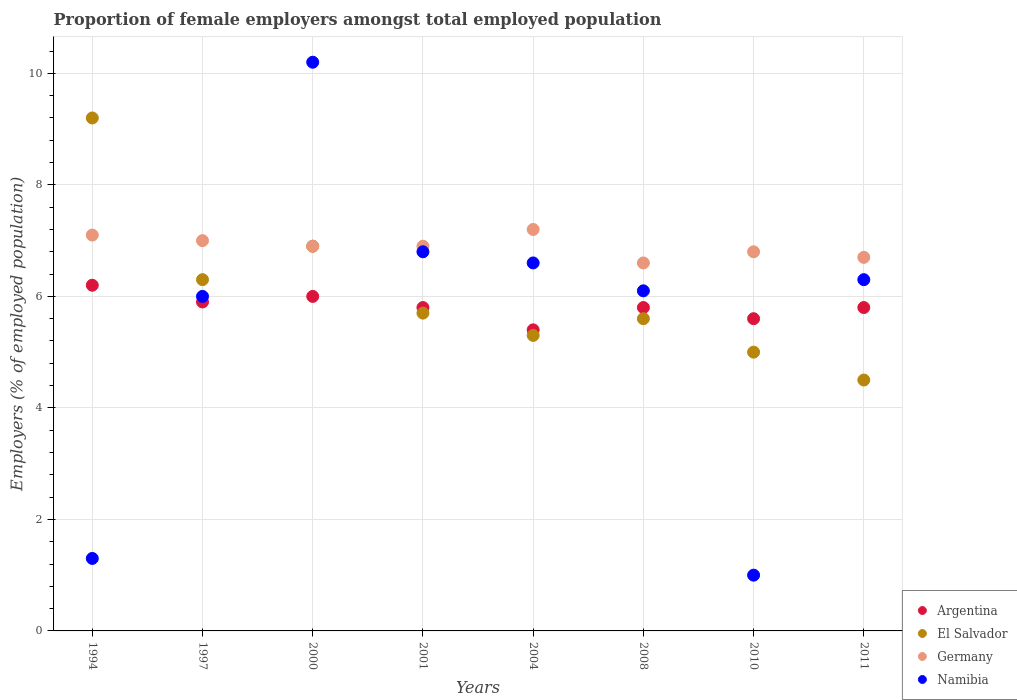How many different coloured dotlines are there?
Your response must be concise. 4. What is the proportion of female employers in Argentina in 1997?
Your response must be concise. 5.9. Across all years, what is the maximum proportion of female employers in El Salvador?
Ensure brevity in your answer.  9.2. Across all years, what is the minimum proportion of female employers in El Salvador?
Your answer should be very brief. 4.5. What is the total proportion of female employers in Argentina in the graph?
Make the answer very short. 46.5. What is the difference between the proportion of female employers in El Salvador in 2004 and that in 2008?
Provide a short and direct response. -0.3. What is the difference between the proportion of female employers in Argentina in 2011 and the proportion of female employers in El Salvador in 2010?
Keep it short and to the point. 0.8. What is the average proportion of female employers in Namibia per year?
Make the answer very short. 5.54. In the year 1994, what is the difference between the proportion of female employers in Argentina and proportion of female employers in Germany?
Ensure brevity in your answer.  -0.9. What is the ratio of the proportion of female employers in Germany in 2000 to that in 2010?
Your answer should be very brief. 1.01. Is the proportion of female employers in Germany in 2001 less than that in 2004?
Offer a terse response. Yes. Is the difference between the proportion of female employers in Argentina in 2008 and 2011 greater than the difference between the proportion of female employers in Germany in 2008 and 2011?
Offer a terse response. Yes. What is the difference between the highest and the second highest proportion of female employers in Argentina?
Provide a succinct answer. 0.2. What is the difference between the highest and the lowest proportion of female employers in Argentina?
Your answer should be compact. 0.8. In how many years, is the proportion of female employers in Argentina greater than the average proportion of female employers in Argentina taken over all years?
Make the answer very short. 3. Is it the case that in every year, the sum of the proportion of female employers in Namibia and proportion of female employers in Argentina  is greater than the sum of proportion of female employers in El Salvador and proportion of female employers in Germany?
Provide a succinct answer. No. Is the proportion of female employers in El Salvador strictly less than the proportion of female employers in Germany over the years?
Offer a terse response. No. How many dotlines are there?
Provide a short and direct response. 4. Where does the legend appear in the graph?
Your answer should be very brief. Bottom right. How many legend labels are there?
Ensure brevity in your answer.  4. How are the legend labels stacked?
Your response must be concise. Vertical. What is the title of the graph?
Your response must be concise. Proportion of female employers amongst total employed population. Does "Somalia" appear as one of the legend labels in the graph?
Your response must be concise. No. What is the label or title of the Y-axis?
Provide a short and direct response. Employers (% of employed population). What is the Employers (% of employed population) of Argentina in 1994?
Ensure brevity in your answer.  6.2. What is the Employers (% of employed population) of El Salvador in 1994?
Offer a very short reply. 9.2. What is the Employers (% of employed population) in Germany in 1994?
Ensure brevity in your answer.  7.1. What is the Employers (% of employed population) in Namibia in 1994?
Provide a short and direct response. 1.3. What is the Employers (% of employed population) of Argentina in 1997?
Your response must be concise. 5.9. What is the Employers (% of employed population) of El Salvador in 1997?
Your answer should be compact. 6.3. What is the Employers (% of employed population) in Namibia in 1997?
Offer a very short reply. 6. What is the Employers (% of employed population) of El Salvador in 2000?
Keep it short and to the point. 6.9. What is the Employers (% of employed population) in Germany in 2000?
Ensure brevity in your answer.  6.9. What is the Employers (% of employed population) in Namibia in 2000?
Offer a terse response. 10.2. What is the Employers (% of employed population) in Argentina in 2001?
Provide a succinct answer. 5.8. What is the Employers (% of employed population) of El Salvador in 2001?
Ensure brevity in your answer.  5.7. What is the Employers (% of employed population) of Germany in 2001?
Give a very brief answer. 6.9. What is the Employers (% of employed population) in Namibia in 2001?
Your answer should be compact. 6.8. What is the Employers (% of employed population) of Argentina in 2004?
Offer a very short reply. 5.4. What is the Employers (% of employed population) in El Salvador in 2004?
Provide a succinct answer. 5.3. What is the Employers (% of employed population) in Germany in 2004?
Make the answer very short. 7.2. What is the Employers (% of employed population) in Namibia in 2004?
Keep it short and to the point. 6.6. What is the Employers (% of employed population) in Argentina in 2008?
Your answer should be very brief. 5.8. What is the Employers (% of employed population) of El Salvador in 2008?
Offer a terse response. 5.6. What is the Employers (% of employed population) of Germany in 2008?
Keep it short and to the point. 6.6. What is the Employers (% of employed population) of Namibia in 2008?
Offer a very short reply. 6.1. What is the Employers (% of employed population) of Argentina in 2010?
Keep it short and to the point. 5.6. What is the Employers (% of employed population) in Germany in 2010?
Make the answer very short. 6.8. What is the Employers (% of employed population) in Namibia in 2010?
Offer a terse response. 1. What is the Employers (% of employed population) in Argentina in 2011?
Offer a terse response. 5.8. What is the Employers (% of employed population) in Germany in 2011?
Your answer should be compact. 6.7. What is the Employers (% of employed population) in Namibia in 2011?
Keep it short and to the point. 6.3. Across all years, what is the maximum Employers (% of employed population) of Argentina?
Provide a short and direct response. 6.2. Across all years, what is the maximum Employers (% of employed population) in El Salvador?
Give a very brief answer. 9.2. Across all years, what is the maximum Employers (% of employed population) in Germany?
Make the answer very short. 7.2. Across all years, what is the maximum Employers (% of employed population) of Namibia?
Your answer should be compact. 10.2. Across all years, what is the minimum Employers (% of employed population) of Argentina?
Ensure brevity in your answer.  5.4. Across all years, what is the minimum Employers (% of employed population) of Germany?
Provide a succinct answer. 6.6. Across all years, what is the minimum Employers (% of employed population) of Namibia?
Make the answer very short. 1. What is the total Employers (% of employed population) of Argentina in the graph?
Offer a very short reply. 46.5. What is the total Employers (% of employed population) in El Salvador in the graph?
Your response must be concise. 48.5. What is the total Employers (% of employed population) of Germany in the graph?
Make the answer very short. 55.2. What is the total Employers (% of employed population) in Namibia in the graph?
Offer a very short reply. 44.3. What is the difference between the Employers (% of employed population) of El Salvador in 1994 and that in 1997?
Offer a terse response. 2.9. What is the difference between the Employers (% of employed population) of Namibia in 1994 and that in 1997?
Your answer should be compact. -4.7. What is the difference between the Employers (% of employed population) in Argentina in 1994 and that in 2000?
Give a very brief answer. 0.2. What is the difference between the Employers (% of employed population) of El Salvador in 1994 and that in 2000?
Ensure brevity in your answer.  2.3. What is the difference between the Employers (% of employed population) of Germany in 1994 and that in 2000?
Offer a terse response. 0.2. What is the difference between the Employers (% of employed population) of Namibia in 1994 and that in 2000?
Provide a succinct answer. -8.9. What is the difference between the Employers (% of employed population) of Namibia in 1994 and that in 2001?
Give a very brief answer. -5.5. What is the difference between the Employers (% of employed population) of Argentina in 1994 and that in 2004?
Your answer should be very brief. 0.8. What is the difference between the Employers (% of employed population) in Germany in 1994 and that in 2004?
Offer a terse response. -0.1. What is the difference between the Employers (% of employed population) of Argentina in 1994 and that in 2008?
Your response must be concise. 0.4. What is the difference between the Employers (% of employed population) in Namibia in 1994 and that in 2008?
Give a very brief answer. -4.8. What is the difference between the Employers (% of employed population) in Argentina in 1994 and that in 2010?
Offer a terse response. 0.6. What is the difference between the Employers (% of employed population) of Germany in 1994 and that in 2010?
Your answer should be very brief. 0.3. What is the difference between the Employers (% of employed population) in Namibia in 1994 and that in 2010?
Your response must be concise. 0.3. What is the difference between the Employers (% of employed population) of El Salvador in 1994 and that in 2011?
Provide a short and direct response. 4.7. What is the difference between the Employers (% of employed population) of Germany in 1994 and that in 2011?
Make the answer very short. 0.4. What is the difference between the Employers (% of employed population) of El Salvador in 1997 and that in 2000?
Offer a terse response. -0.6. What is the difference between the Employers (% of employed population) in Germany in 1997 and that in 2000?
Give a very brief answer. 0.1. What is the difference between the Employers (% of employed population) of Germany in 1997 and that in 2001?
Offer a terse response. 0.1. What is the difference between the Employers (% of employed population) in Argentina in 1997 and that in 2004?
Provide a succinct answer. 0.5. What is the difference between the Employers (% of employed population) of El Salvador in 1997 and that in 2004?
Your answer should be compact. 1. What is the difference between the Employers (% of employed population) in Argentina in 1997 and that in 2008?
Make the answer very short. 0.1. What is the difference between the Employers (% of employed population) of El Salvador in 1997 and that in 2008?
Keep it short and to the point. 0.7. What is the difference between the Employers (% of employed population) in Germany in 1997 and that in 2010?
Your response must be concise. 0.2. What is the difference between the Employers (% of employed population) of El Salvador in 1997 and that in 2011?
Your answer should be very brief. 1.8. What is the difference between the Employers (% of employed population) of Germany in 1997 and that in 2011?
Provide a short and direct response. 0.3. What is the difference between the Employers (% of employed population) in Argentina in 2000 and that in 2001?
Your response must be concise. 0.2. What is the difference between the Employers (% of employed population) in El Salvador in 2000 and that in 2001?
Your answer should be compact. 1.2. What is the difference between the Employers (% of employed population) of Germany in 2000 and that in 2001?
Your response must be concise. 0. What is the difference between the Employers (% of employed population) in Namibia in 2000 and that in 2001?
Your response must be concise. 3.4. What is the difference between the Employers (% of employed population) of Argentina in 2000 and that in 2004?
Make the answer very short. 0.6. What is the difference between the Employers (% of employed population) of El Salvador in 2000 and that in 2004?
Provide a succinct answer. 1.6. What is the difference between the Employers (% of employed population) of Argentina in 2000 and that in 2008?
Give a very brief answer. 0.2. What is the difference between the Employers (% of employed population) in Namibia in 2000 and that in 2010?
Keep it short and to the point. 9.2. What is the difference between the Employers (% of employed population) of Argentina in 2000 and that in 2011?
Make the answer very short. 0.2. What is the difference between the Employers (% of employed population) of El Salvador in 2000 and that in 2011?
Your response must be concise. 2.4. What is the difference between the Employers (% of employed population) of Argentina in 2001 and that in 2004?
Your response must be concise. 0.4. What is the difference between the Employers (% of employed population) of El Salvador in 2001 and that in 2004?
Give a very brief answer. 0.4. What is the difference between the Employers (% of employed population) in Namibia in 2001 and that in 2004?
Give a very brief answer. 0.2. What is the difference between the Employers (% of employed population) of Argentina in 2001 and that in 2010?
Offer a terse response. 0.2. What is the difference between the Employers (% of employed population) in El Salvador in 2001 and that in 2010?
Provide a succinct answer. 0.7. What is the difference between the Employers (% of employed population) in Germany in 2001 and that in 2010?
Your response must be concise. 0.1. What is the difference between the Employers (% of employed population) in Germany in 2001 and that in 2011?
Your answer should be compact. 0.2. What is the difference between the Employers (% of employed population) in Argentina in 2004 and that in 2008?
Your answer should be very brief. -0.4. What is the difference between the Employers (% of employed population) of El Salvador in 2004 and that in 2010?
Make the answer very short. 0.3. What is the difference between the Employers (% of employed population) in Namibia in 2004 and that in 2010?
Offer a very short reply. 5.6. What is the difference between the Employers (% of employed population) in Argentina in 2004 and that in 2011?
Keep it short and to the point. -0.4. What is the difference between the Employers (% of employed population) in El Salvador in 2004 and that in 2011?
Give a very brief answer. 0.8. What is the difference between the Employers (% of employed population) of Germany in 2004 and that in 2011?
Offer a terse response. 0.5. What is the difference between the Employers (% of employed population) of Namibia in 2008 and that in 2010?
Provide a succinct answer. 5.1. What is the difference between the Employers (% of employed population) of El Salvador in 2008 and that in 2011?
Offer a terse response. 1.1. What is the difference between the Employers (% of employed population) of Germany in 2008 and that in 2011?
Your answer should be very brief. -0.1. What is the difference between the Employers (% of employed population) in Namibia in 2008 and that in 2011?
Your answer should be very brief. -0.2. What is the difference between the Employers (% of employed population) in Argentina in 2010 and that in 2011?
Your response must be concise. -0.2. What is the difference between the Employers (% of employed population) of El Salvador in 2010 and that in 2011?
Ensure brevity in your answer.  0.5. What is the difference between the Employers (% of employed population) of Namibia in 2010 and that in 2011?
Ensure brevity in your answer.  -5.3. What is the difference between the Employers (% of employed population) in Argentina in 1994 and the Employers (% of employed population) in El Salvador in 1997?
Offer a very short reply. -0.1. What is the difference between the Employers (% of employed population) in El Salvador in 1994 and the Employers (% of employed population) in Namibia in 1997?
Offer a terse response. 3.2. What is the difference between the Employers (% of employed population) of Argentina in 1994 and the Employers (% of employed population) of El Salvador in 2000?
Your response must be concise. -0.7. What is the difference between the Employers (% of employed population) of Argentina in 1994 and the Employers (% of employed population) of Germany in 2000?
Ensure brevity in your answer.  -0.7. What is the difference between the Employers (% of employed population) of El Salvador in 1994 and the Employers (% of employed population) of Namibia in 2001?
Keep it short and to the point. 2.4. What is the difference between the Employers (% of employed population) of Germany in 1994 and the Employers (% of employed population) of Namibia in 2001?
Your response must be concise. 0.3. What is the difference between the Employers (% of employed population) in Argentina in 1994 and the Employers (% of employed population) in El Salvador in 2004?
Your answer should be compact. 0.9. What is the difference between the Employers (% of employed population) in Argentina in 1994 and the Employers (% of employed population) in Germany in 2004?
Offer a very short reply. -1. What is the difference between the Employers (% of employed population) in Argentina in 1994 and the Employers (% of employed population) in Namibia in 2004?
Your answer should be very brief. -0.4. What is the difference between the Employers (% of employed population) of El Salvador in 1994 and the Employers (% of employed population) of Germany in 2004?
Offer a terse response. 2. What is the difference between the Employers (% of employed population) of El Salvador in 1994 and the Employers (% of employed population) of Namibia in 2004?
Provide a short and direct response. 2.6. What is the difference between the Employers (% of employed population) of Argentina in 1994 and the Employers (% of employed population) of El Salvador in 2008?
Ensure brevity in your answer.  0.6. What is the difference between the Employers (% of employed population) in Argentina in 1994 and the Employers (% of employed population) in Germany in 2008?
Offer a very short reply. -0.4. What is the difference between the Employers (% of employed population) in El Salvador in 1994 and the Employers (% of employed population) in Germany in 2008?
Your response must be concise. 2.6. What is the difference between the Employers (% of employed population) in El Salvador in 1994 and the Employers (% of employed population) in Namibia in 2008?
Your answer should be compact. 3.1. What is the difference between the Employers (% of employed population) of Germany in 1994 and the Employers (% of employed population) of Namibia in 2008?
Offer a terse response. 1. What is the difference between the Employers (% of employed population) of Germany in 1994 and the Employers (% of employed population) of Namibia in 2011?
Your answer should be compact. 0.8. What is the difference between the Employers (% of employed population) of Argentina in 1997 and the Employers (% of employed population) of El Salvador in 2000?
Keep it short and to the point. -1. What is the difference between the Employers (% of employed population) in Argentina in 1997 and the Employers (% of employed population) in Namibia in 2000?
Offer a very short reply. -4.3. What is the difference between the Employers (% of employed population) of El Salvador in 1997 and the Employers (% of employed population) of Namibia in 2000?
Provide a short and direct response. -3.9. What is the difference between the Employers (% of employed population) in Germany in 1997 and the Employers (% of employed population) in Namibia in 2000?
Provide a short and direct response. -3.2. What is the difference between the Employers (% of employed population) of Argentina in 1997 and the Employers (% of employed population) of El Salvador in 2001?
Make the answer very short. 0.2. What is the difference between the Employers (% of employed population) in Argentina in 1997 and the Employers (% of employed population) in Germany in 2001?
Provide a succinct answer. -1. What is the difference between the Employers (% of employed population) of Argentina in 1997 and the Employers (% of employed population) of Namibia in 2001?
Your answer should be very brief. -0.9. What is the difference between the Employers (% of employed population) of El Salvador in 1997 and the Employers (% of employed population) of Namibia in 2001?
Ensure brevity in your answer.  -0.5. What is the difference between the Employers (% of employed population) of Argentina in 1997 and the Employers (% of employed population) of Germany in 2004?
Provide a short and direct response. -1.3. What is the difference between the Employers (% of employed population) of Argentina in 1997 and the Employers (% of employed population) of Namibia in 2004?
Your answer should be compact. -0.7. What is the difference between the Employers (% of employed population) in El Salvador in 1997 and the Employers (% of employed population) in Germany in 2004?
Give a very brief answer. -0.9. What is the difference between the Employers (% of employed population) of El Salvador in 1997 and the Employers (% of employed population) of Namibia in 2004?
Your answer should be very brief. -0.3. What is the difference between the Employers (% of employed population) in Argentina in 1997 and the Employers (% of employed population) in Germany in 2008?
Keep it short and to the point. -0.7. What is the difference between the Employers (% of employed population) in Argentina in 1997 and the Employers (% of employed population) in Namibia in 2008?
Your answer should be very brief. -0.2. What is the difference between the Employers (% of employed population) in El Salvador in 1997 and the Employers (% of employed population) in Germany in 2008?
Provide a succinct answer. -0.3. What is the difference between the Employers (% of employed population) in Argentina in 1997 and the Employers (% of employed population) in El Salvador in 2010?
Your answer should be very brief. 0.9. What is the difference between the Employers (% of employed population) of Germany in 1997 and the Employers (% of employed population) of Namibia in 2010?
Offer a terse response. 6. What is the difference between the Employers (% of employed population) of Argentina in 1997 and the Employers (% of employed population) of Namibia in 2011?
Ensure brevity in your answer.  -0.4. What is the difference between the Employers (% of employed population) of El Salvador in 2000 and the Employers (% of employed population) of Namibia in 2001?
Provide a short and direct response. 0.1. What is the difference between the Employers (% of employed population) of Argentina in 2000 and the Employers (% of employed population) of El Salvador in 2004?
Make the answer very short. 0.7. What is the difference between the Employers (% of employed population) in Argentina in 2000 and the Employers (% of employed population) in Germany in 2004?
Give a very brief answer. -1.2. What is the difference between the Employers (% of employed population) in El Salvador in 2000 and the Employers (% of employed population) in Namibia in 2004?
Make the answer very short. 0.3. What is the difference between the Employers (% of employed population) in Argentina in 2000 and the Employers (% of employed population) in El Salvador in 2010?
Offer a very short reply. 1. What is the difference between the Employers (% of employed population) of Argentina in 2000 and the Employers (% of employed population) of Germany in 2010?
Ensure brevity in your answer.  -0.8. What is the difference between the Employers (% of employed population) in El Salvador in 2000 and the Employers (% of employed population) in Namibia in 2010?
Your response must be concise. 5.9. What is the difference between the Employers (% of employed population) of Argentina in 2000 and the Employers (% of employed population) of El Salvador in 2011?
Give a very brief answer. 1.5. What is the difference between the Employers (% of employed population) in Argentina in 2000 and the Employers (% of employed population) in Namibia in 2011?
Your answer should be very brief. -0.3. What is the difference between the Employers (% of employed population) in Germany in 2000 and the Employers (% of employed population) in Namibia in 2011?
Make the answer very short. 0.6. What is the difference between the Employers (% of employed population) in Argentina in 2001 and the Employers (% of employed population) in El Salvador in 2004?
Your answer should be very brief. 0.5. What is the difference between the Employers (% of employed population) of Argentina in 2001 and the Employers (% of employed population) of Germany in 2004?
Your answer should be compact. -1.4. What is the difference between the Employers (% of employed population) of El Salvador in 2001 and the Employers (% of employed population) of Germany in 2004?
Provide a succinct answer. -1.5. What is the difference between the Employers (% of employed population) of Argentina in 2001 and the Employers (% of employed population) of Germany in 2008?
Give a very brief answer. -0.8. What is the difference between the Employers (% of employed population) of El Salvador in 2001 and the Employers (% of employed population) of Germany in 2008?
Provide a succinct answer. -0.9. What is the difference between the Employers (% of employed population) of Germany in 2001 and the Employers (% of employed population) of Namibia in 2008?
Your answer should be very brief. 0.8. What is the difference between the Employers (% of employed population) of El Salvador in 2001 and the Employers (% of employed population) of Germany in 2010?
Offer a very short reply. -1.1. What is the difference between the Employers (% of employed population) in El Salvador in 2001 and the Employers (% of employed population) in Namibia in 2010?
Offer a terse response. 4.7. What is the difference between the Employers (% of employed population) in Germany in 2001 and the Employers (% of employed population) in Namibia in 2010?
Make the answer very short. 5.9. What is the difference between the Employers (% of employed population) of Argentina in 2001 and the Employers (% of employed population) of Germany in 2011?
Provide a short and direct response. -0.9. What is the difference between the Employers (% of employed population) of Argentina in 2001 and the Employers (% of employed population) of Namibia in 2011?
Your response must be concise. -0.5. What is the difference between the Employers (% of employed population) of El Salvador in 2001 and the Employers (% of employed population) of Germany in 2011?
Your response must be concise. -1. What is the difference between the Employers (% of employed population) in El Salvador in 2001 and the Employers (% of employed population) in Namibia in 2011?
Offer a terse response. -0.6. What is the difference between the Employers (% of employed population) of Argentina in 2004 and the Employers (% of employed population) of Germany in 2008?
Ensure brevity in your answer.  -1.2. What is the difference between the Employers (% of employed population) in Argentina in 2004 and the Employers (% of employed population) in Germany in 2010?
Provide a succinct answer. -1.4. What is the difference between the Employers (% of employed population) in Argentina in 2004 and the Employers (% of employed population) in Namibia in 2010?
Make the answer very short. 4.4. What is the difference between the Employers (% of employed population) in El Salvador in 2004 and the Employers (% of employed population) in Germany in 2010?
Provide a short and direct response. -1.5. What is the difference between the Employers (% of employed population) of Argentina in 2004 and the Employers (% of employed population) of El Salvador in 2011?
Make the answer very short. 0.9. What is the difference between the Employers (% of employed population) in Argentina in 2004 and the Employers (% of employed population) in Namibia in 2011?
Provide a short and direct response. -0.9. What is the difference between the Employers (% of employed population) in El Salvador in 2004 and the Employers (% of employed population) in Germany in 2011?
Your answer should be compact. -1.4. What is the difference between the Employers (% of employed population) in El Salvador in 2004 and the Employers (% of employed population) in Namibia in 2011?
Give a very brief answer. -1. What is the difference between the Employers (% of employed population) of Argentina in 2008 and the Employers (% of employed population) of El Salvador in 2010?
Your answer should be very brief. 0.8. What is the difference between the Employers (% of employed population) of El Salvador in 2008 and the Employers (% of employed population) of Germany in 2010?
Your response must be concise. -1.2. What is the difference between the Employers (% of employed population) in El Salvador in 2008 and the Employers (% of employed population) in Namibia in 2010?
Ensure brevity in your answer.  4.6. What is the difference between the Employers (% of employed population) of Argentina in 2008 and the Employers (% of employed population) of El Salvador in 2011?
Give a very brief answer. 1.3. What is the difference between the Employers (% of employed population) in Argentina in 2008 and the Employers (% of employed population) in Namibia in 2011?
Keep it short and to the point. -0.5. What is the difference between the Employers (% of employed population) of El Salvador in 2008 and the Employers (% of employed population) of Namibia in 2011?
Make the answer very short. -0.7. What is the difference between the Employers (% of employed population) of Germany in 2008 and the Employers (% of employed population) of Namibia in 2011?
Offer a very short reply. 0.3. What is the difference between the Employers (% of employed population) in Argentina in 2010 and the Employers (% of employed population) in Germany in 2011?
Your answer should be compact. -1.1. What is the difference between the Employers (% of employed population) in Argentina in 2010 and the Employers (% of employed population) in Namibia in 2011?
Your answer should be compact. -0.7. What is the difference between the Employers (% of employed population) of Germany in 2010 and the Employers (% of employed population) of Namibia in 2011?
Your answer should be compact. 0.5. What is the average Employers (% of employed population) in Argentina per year?
Keep it short and to the point. 5.81. What is the average Employers (% of employed population) of El Salvador per year?
Offer a terse response. 6.06. What is the average Employers (% of employed population) of Germany per year?
Offer a terse response. 6.9. What is the average Employers (% of employed population) of Namibia per year?
Provide a short and direct response. 5.54. In the year 1994, what is the difference between the Employers (% of employed population) in Argentina and Employers (% of employed population) in El Salvador?
Provide a succinct answer. -3. In the year 1994, what is the difference between the Employers (% of employed population) of Argentina and Employers (% of employed population) of Germany?
Provide a succinct answer. -0.9. In the year 1994, what is the difference between the Employers (% of employed population) of El Salvador and Employers (% of employed population) of Namibia?
Your answer should be compact. 7.9. In the year 1994, what is the difference between the Employers (% of employed population) of Germany and Employers (% of employed population) of Namibia?
Offer a terse response. 5.8. In the year 1997, what is the difference between the Employers (% of employed population) of Argentina and Employers (% of employed population) of El Salvador?
Offer a very short reply. -0.4. In the year 1997, what is the difference between the Employers (% of employed population) in El Salvador and Employers (% of employed population) in Germany?
Your answer should be very brief. -0.7. In the year 1997, what is the difference between the Employers (% of employed population) of El Salvador and Employers (% of employed population) of Namibia?
Ensure brevity in your answer.  0.3. In the year 1997, what is the difference between the Employers (% of employed population) in Germany and Employers (% of employed population) in Namibia?
Provide a short and direct response. 1. In the year 2000, what is the difference between the Employers (% of employed population) of El Salvador and Employers (% of employed population) of Germany?
Keep it short and to the point. 0. In the year 2000, what is the difference between the Employers (% of employed population) of El Salvador and Employers (% of employed population) of Namibia?
Your response must be concise. -3.3. In the year 2000, what is the difference between the Employers (% of employed population) of Germany and Employers (% of employed population) of Namibia?
Keep it short and to the point. -3.3. In the year 2001, what is the difference between the Employers (% of employed population) of Argentina and Employers (% of employed population) of El Salvador?
Your answer should be very brief. 0.1. In the year 2001, what is the difference between the Employers (% of employed population) of El Salvador and Employers (% of employed population) of Germany?
Make the answer very short. -1.2. In the year 2001, what is the difference between the Employers (% of employed population) in El Salvador and Employers (% of employed population) in Namibia?
Your answer should be compact. -1.1. In the year 2001, what is the difference between the Employers (% of employed population) of Germany and Employers (% of employed population) of Namibia?
Give a very brief answer. 0.1. In the year 2008, what is the difference between the Employers (% of employed population) in Argentina and Employers (% of employed population) in El Salvador?
Give a very brief answer. 0.2. In the year 2008, what is the difference between the Employers (% of employed population) of Argentina and Employers (% of employed population) of Namibia?
Keep it short and to the point. -0.3. In the year 2008, what is the difference between the Employers (% of employed population) in El Salvador and Employers (% of employed population) in Namibia?
Offer a very short reply. -0.5. In the year 2010, what is the difference between the Employers (% of employed population) in Argentina and Employers (% of employed population) in Germany?
Give a very brief answer. -1.2. In the year 2010, what is the difference between the Employers (% of employed population) in El Salvador and Employers (% of employed population) in Germany?
Your answer should be very brief. -1.8. In the year 2010, what is the difference between the Employers (% of employed population) in El Salvador and Employers (% of employed population) in Namibia?
Make the answer very short. 4. In the year 2010, what is the difference between the Employers (% of employed population) in Germany and Employers (% of employed population) in Namibia?
Keep it short and to the point. 5.8. In the year 2011, what is the difference between the Employers (% of employed population) of El Salvador and Employers (% of employed population) of Namibia?
Provide a short and direct response. -1.8. What is the ratio of the Employers (% of employed population) of Argentina in 1994 to that in 1997?
Provide a short and direct response. 1.05. What is the ratio of the Employers (% of employed population) in El Salvador in 1994 to that in 1997?
Your answer should be compact. 1.46. What is the ratio of the Employers (% of employed population) in Germany in 1994 to that in 1997?
Your answer should be compact. 1.01. What is the ratio of the Employers (% of employed population) in Namibia in 1994 to that in 1997?
Provide a succinct answer. 0.22. What is the ratio of the Employers (% of employed population) of Germany in 1994 to that in 2000?
Keep it short and to the point. 1.03. What is the ratio of the Employers (% of employed population) of Namibia in 1994 to that in 2000?
Give a very brief answer. 0.13. What is the ratio of the Employers (% of employed population) in Argentina in 1994 to that in 2001?
Keep it short and to the point. 1.07. What is the ratio of the Employers (% of employed population) of El Salvador in 1994 to that in 2001?
Offer a very short reply. 1.61. What is the ratio of the Employers (% of employed population) in Namibia in 1994 to that in 2001?
Give a very brief answer. 0.19. What is the ratio of the Employers (% of employed population) in Argentina in 1994 to that in 2004?
Make the answer very short. 1.15. What is the ratio of the Employers (% of employed population) of El Salvador in 1994 to that in 2004?
Ensure brevity in your answer.  1.74. What is the ratio of the Employers (% of employed population) in Germany in 1994 to that in 2004?
Your response must be concise. 0.99. What is the ratio of the Employers (% of employed population) of Namibia in 1994 to that in 2004?
Ensure brevity in your answer.  0.2. What is the ratio of the Employers (% of employed population) in Argentina in 1994 to that in 2008?
Your answer should be compact. 1.07. What is the ratio of the Employers (% of employed population) in El Salvador in 1994 to that in 2008?
Your answer should be compact. 1.64. What is the ratio of the Employers (% of employed population) in Germany in 1994 to that in 2008?
Offer a terse response. 1.08. What is the ratio of the Employers (% of employed population) of Namibia in 1994 to that in 2008?
Your response must be concise. 0.21. What is the ratio of the Employers (% of employed population) of Argentina in 1994 to that in 2010?
Give a very brief answer. 1.11. What is the ratio of the Employers (% of employed population) of El Salvador in 1994 to that in 2010?
Make the answer very short. 1.84. What is the ratio of the Employers (% of employed population) in Germany in 1994 to that in 2010?
Keep it short and to the point. 1.04. What is the ratio of the Employers (% of employed population) in Namibia in 1994 to that in 2010?
Provide a succinct answer. 1.3. What is the ratio of the Employers (% of employed population) in Argentina in 1994 to that in 2011?
Your answer should be compact. 1.07. What is the ratio of the Employers (% of employed population) of El Salvador in 1994 to that in 2011?
Ensure brevity in your answer.  2.04. What is the ratio of the Employers (% of employed population) of Germany in 1994 to that in 2011?
Make the answer very short. 1.06. What is the ratio of the Employers (% of employed population) in Namibia in 1994 to that in 2011?
Give a very brief answer. 0.21. What is the ratio of the Employers (% of employed population) in Argentina in 1997 to that in 2000?
Provide a succinct answer. 0.98. What is the ratio of the Employers (% of employed population) in El Salvador in 1997 to that in 2000?
Make the answer very short. 0.91. What is the ratio of the Employers (% of employed population) of Germany in 1997 to that in 2000?
Your answer should be compact. 1.01. What is the ratio of the Employers (% of employed population) in Namibia in 1997 to that in 2000?
Offer a terse response. 0.59. What is the ratio of the Employers (% of employed population) of Argentina in 1997 to that in 2001?
Your answer should be compact. 1.02. What is the ratio of the Employers (% of employed population) of El Salvador in 1997 to that in 2001?
Offer a very short reply. 1.11. What is the ratio of the Employers (% of employed population) of Germany in 1997 to that in 2001?
Provide a succinct answer. 1.01. What is the ratio of the Employers (% of employed population) of Namibia in 1997 to that in 2001?
Give a very brief answer. 0.88. What is the ratio of the Employers (% of employed population) of Argentina in 1997 to that in 2004?
Give a very brief answer. 1.09. What is the ratio of the Employers (% of employed population) in El Salvador in 1997 to that in 2004?
Ensure brevity in your answer.  1.19. What is the ratio of the Employers (% of employed population) of Germany in 1997 to that in 2004?
Make the answer very short. 0.97. What is the ratio of the Employers (% of employed population) of Argentina in 1997 to that in 2008?
Provide a succinct answer. 1.02. What is the ratio of the Employers (% of employed population) in Germany in 1997 to that in 2008?
Make the answer very short. 1.06. What is the ratio of the Employers (% of employed population) in Namibia in 1997 to that in 2008?
Provide a succinct answer. 0.98. What is the ratio of the Employers (% of employed population) of Argentina in 1997 to that in 2010?
Provide a succinct answer. 1.05. What is the ratio of the Employers (% of employed population) in El Salvador in 1997 to that in 2010?
Provide a short and direct response. 1.26. What is the ratio of the Employers (% of employed population) in Germany in 1997 to that in 2010?
Make the answer very short. 1.03. What is the ratio of the Employers (% of employed population) of Namibia in 1997 to that in 2010?
Provide a succinct answer. 6. What is the ratio of the Employers (% of employed population) of Argentina in 1997 to that in 2011?
Provide a succinct answer. 1.02. What is the ratio of the Employers (% of employed population) of El Salvador in 1997 to that in 2011?
Provide a short and direct response. 1.4. What is the ratio of the Employers (% of employed population) in Germany in 1997 to that in 2011?
Your response must be concise. 1.04. What is the ratio of the Employers (% of employed population) in Namibia in 1997 to that in 2011?
Offer a terse response. 0.95. What is the ratio of the Employers (% of employed population) of Argentina in 2000 to that in 2001?
Make the answer very short. 1.03. What is the ratio of the Employers (% of employed population) of El Salvador in 2000 to that in 2001?
Give a very brief answer. 1.21. What is the ratio of the Employers (% of employed population) in Germany in 2000 to that in 2001?
Offer a very short reply. 1. What is the ratio of the Employers (% of employed population) of Namibia in 2000 to that in 2001?
Offer a terse response. 1.5. What is the ratio of the Employers (% of employed population) in Argentina in 2000 to that in 2004?
Make the answer very short. 1.11. What is the ratio of the Employers (% of employed population) in El Salvador in 2000 to that in 2004?
Ensure brevity in your answer.  1.3. What is the ratio of the Employers (% of employed population) in Namibia in 2000 to that in 2004?
Your response must be concise. 1.55. What is the ratio of the Employers (% of employed population) in Argentina in 2000 to that in 2008?
Make the answer very short. 1.03. What is the ratio of the Employers (% of employed population) of El Salvador in 2000 to that in 2008?
Your answer should be compact. 1.23. What is the ratio of the Employers (% of employed population) in Germany in 2000 to that in 2008?
Make the answer very short. 1.05. What is the ratio of the Employers (% of employed population) in Namibia in 2000 to that in 2008?
Provide a succinct answer. 1.67. What is the ratio of the Employers (% of employed population) in Argentina in 2000 to that in 2010?
Make the answer very short. 1.07. What is the ratio of the Employers (% of employed population) in El Salvador in 2000 to that in 2010?
Provide a short and direct response. 1.38. What is the ratio of the Employers (% of employed population) in Germany in 2000 to that in 2010?
Provide a succinct answer. 1.01. What is the ratio of the Employers (% of employed population) of Argentina in 2000 to that in 2011?
Your response must be concise. 1.03. What is the ratio of the Employers (% of employed population) in El Salvador in 2000 to that in 2011?
Make the answer very short. 1.53. What is the ratio of the Employers (% of employed population) of Germany in 2000 to that in 2011?
Give a very brief answer. 1.03. What is the ratio of the Employers (% of employed population) in Namibia in 2000 to that in 2011?
Your answer should be compact. 1.62. What is the ratio of the Employers (% of employed population) of Argentina in 2001 to that in 2004?
Your response must be concise. 1.07. What is the ratio of the Employers (% of employed population) of El Salvador in 2001 to that in 2004?
Provide a short and direct response. 1.08. What is the ratio of the Employers (% of employed population) of Germany in 2001 to that in 2004?
Make the answer very short. 0.96. What is the ratio of the Employers (% of employed population) of Namibia in 2001 to that in 2004?
Ensure brevity in your answer.  1.03. What is the ratio of the Employers (% of employed population) in El Salvador in 2001 to that in 2008?
Make the answer very short. 1.02. What is the ratio of the Employers (% of employed population) of Germany in 2001 to that in 2008?
Provide a succinct answer. 1.05. What is the ratio of the Employers (% of employed population) of Namibia in 2001 to that in 2008?
Your answer should be compact. 1.11. What is the ratio of the Employers (% of employed population) in Argentina in 2001 to that in 2010?
Provide a succinct answer. 1.04. What is the ratio of the Employers (% of employed population) of El Salvador in 2001 to that in 2010?
Offer a very short reply. 1.14. What is the ratio of the Employers (% of employed population) in Germany in 2001 to that in 2010?
Make the answer very short. 1.01. What is the ratio of the Employers (% of employed population) of Argentina in 2001 to that in 2011?
Offer a terse response. 1. What is the ratio of the Employers (% of employed population) of El Salvador in 2001 to that in 2011?
Your response must be concise. 1.27. What is the ratio of the Employers (% of employed population) in Germany in 2001 to that in 2011?
Offer a terse response. 1.03. What is the ratio of the Employers (% of employed population) of Namibia in 2001 to that in 2011?
Keep it short and to the point. 1.08. What is the ratio of the Employers (% of employed population) of El Salvador in 2004 to that in 2008?
Ensure brevity in your answer.  0.95. What is the ratio of the Employers (% of employed population) of Namibia in 2004 to that in 2008?
Ensure brevity in your answer.  1.08. What is the ratio of the Employers (% of employed population) in Argentina in 2004 to that in 2010?
Provide a succinct answer. 0.96. What is the ratio of the Employers (% of employed population) of El Salvador in 2004 to that in 2010?
Provide a succinct answer. 1.06. What is the ratio of the Employers (% of employed population) of Germany in 2004 to that in 2010?
Keep it short and to the point. 1.06. What is the ratio of the Employers (% of employed population) in Argentina in 2004 to that in 2011?
Your answer should be compact. 0.93. What is the ratio of the Employers (% of employed population) of El Salvador in 2004 to that in 2011?
Offer a terse response. 1.18. What is the ratio of the Employers (% of employed population) of Germany in 2004 to that in 2011?
Give a very brief answer. 1.07. What is the ratio of the Employers (% of employed population) in Namibia in 2004 to that in 2011?
Ensure brevity in your answer.  1.05. What is the ratio of the Employers (% of employed population) of Argentina in 2008 to that in 2010?
Your response must be concise. 1.04. What is the ratio of the Employers (% of employed population) in El Salvador in 2008 to that in 2010?
Provide a short and direct response. 1.12. What is the ratio of the Employers (% of employed population) of Germany in 2008 to that in 2010?
Your answer should be very brief. 0.97. What is the ratio of the Employers (% of employed population) in Namibia in 2008 to that in 2010?
Keep it short and to the point. 6.1. What is the ratio of the Employers (% of employed population) in Argentina in 2008 to that in 2011?
Provide a succinct answer. 1. What is the ratio of the Employers (% of employed population) in El Salvador in 2008 to that in 2011?
Keep it short and to the point. 1.24. What is the ratio of the Employers (% of employed population) of Germany in 2008 to that in 2011?
Provide a short and direct response. 0.99. What is the ratio of the Employers (% of employed population) of Namibia in 2008 to that in 2011?
Make the answer very short. 0.97. What is the ratio of the Employers (% of employed population) in Argentina in 2010 to that in 2011?
Ensure brevity in your answer.  0.97. What is the ratio of the Employers (% of employed population) of Germany in 2010 to that in 2011?
Offer a very short reply. 1.01. What is the ratio of the Employers (% of employed population) in Namibia in 2010 to that in 2011?
Provide a short and direct response. 0.16. What is the difference between the highest and the second highest Employers (% of employed population) in Argentina?
Keep it short and to the point. 0.2. What is the difference between the highest and the second highest Employers (% of employed population) in El Salvador?
Provide a succinct answer. 2.3. What is the difference between the highest and the second highest Employers (% of employed population) in Namibia?
Offer a very short reply. 3.4. What is the difference between the highest and the lowest Employers (% of employed population) in Argentina?
Provide a succinct answer. 0.8. What is the difference between the highest and the lowest Employers (% of employed population) of Germany?
Ensure brevity in your answer.  0.6. 